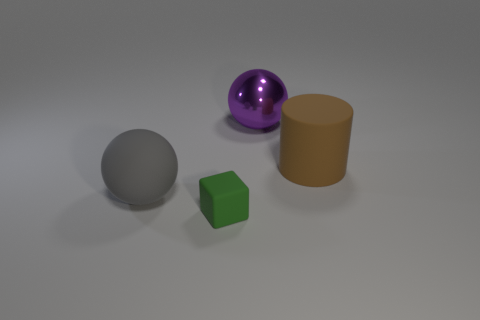How many metallic things are big green blocks or big gray spheres?
Make the answer very short. 0. What is the color of the other thing that is the same shape as the purple metallic object?
Provide a succinct answer. Gray. What number of objects are big brown cylinders or green rubber things?
Offer a very short reply. 2. What shape is the large object that is the same material as the brown cylinder?
Offer a terse response. Sphere. How many large objects are metal balls or brown metal cylinders?
Provide a succinct answer. 1. What number of large brown cylinders are to the right of the large sphere that is behind the big rubber thing that is behind the large gray matte sphere?
Keep it short and to the point. 1. There is a sphere that is on the right side of the rubber block; does it have the same size as the green cube?
Your answer should be very brief. No. Are there fewer gray matte spheres that are to the right of the big gray sphere than green matte cubes in front of the tiny green object?
Offer a terse response. No. Do the cube and the large rubber cylinder have the same color?
Provide a succinct answer. No. Are there fewer spheres that are behind the big brown matte object than purple metallic balls?
Provide a succinct answer. No. 